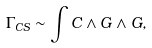Convert formula to latex. <formula><loc_0><loc_0><loc_500><loc_500>\Gamma _ { C S } \sim \int C \wedge G \wedge G ,</formula> 